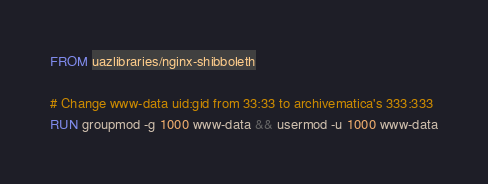<code> <loc_0><loc_0><loc_500><loc_500><_Dockerfile_>FROM uazlibraries/nginx-shibboleth

# Change www-data uid:gid from 33:33 to archivematica's 333:333
RUN groupmod -g 1000 www-data && usermod -u 1000 www-data
</code> 